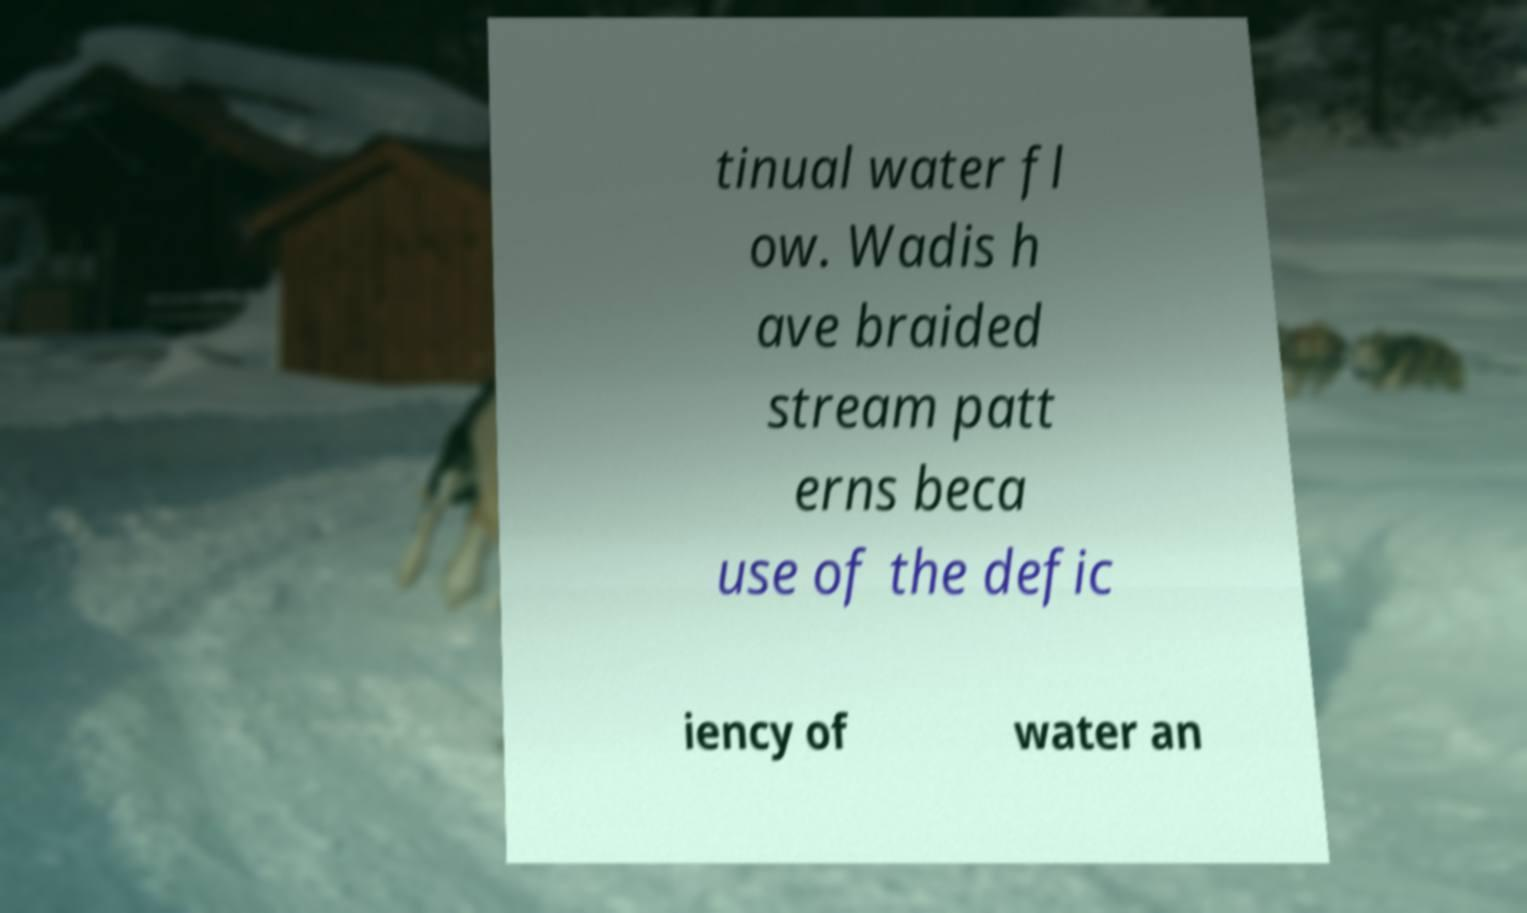What messages or text are displayed in this image? I need them in a readable, typed format. tinual water fl ow. Wadis h ave braided stream patt erns beca use of the defic iency of water an 